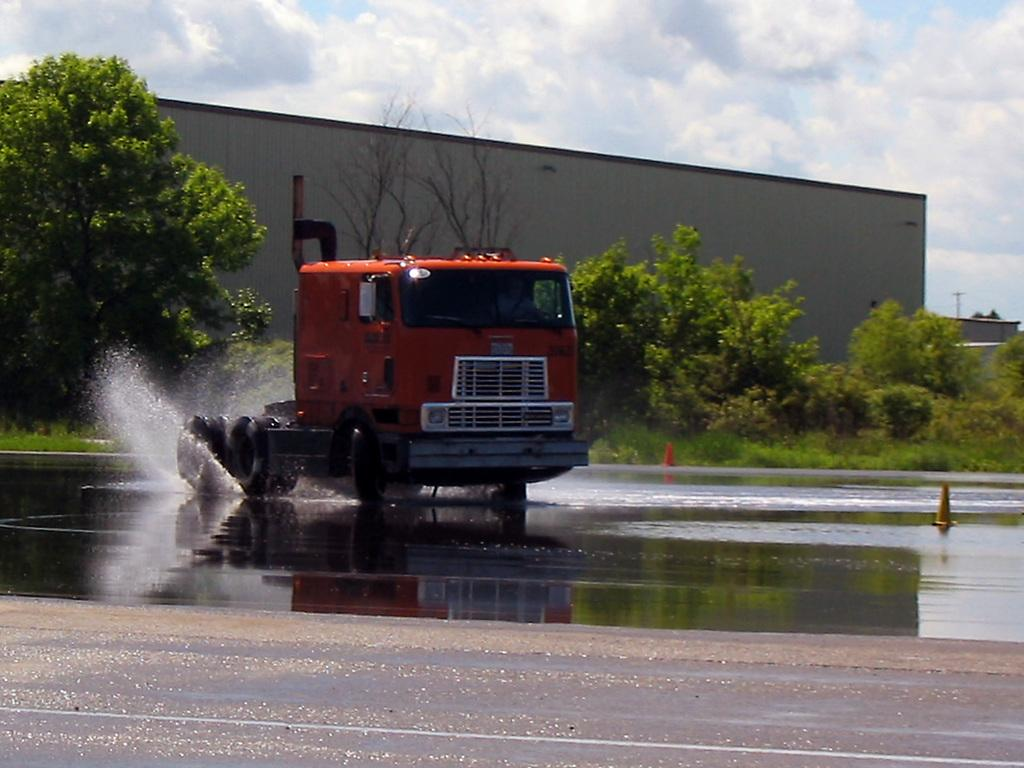What is on the road in the image? There is a vehicle on the road in the image. What can be seen besides the vehicle on the road? Water is visible in the image. What safety measures are present in the image? Traffic cones are present in the image. What type of natural scenery is visible in the background of the image? There are trees in the background of the image. What part of the sky is visible in the image? The sky is visible in the background of the image. What type of structure can be seen in the image? There is a shed in the image. What other object is present in the image? There is a pole in the image. What type of toothpaste is being advertised on the pole in the image? There is no toothpaste being advertised on the pole in the image. What emotion is the cow expressing in the image? There is no cow present in the image. 